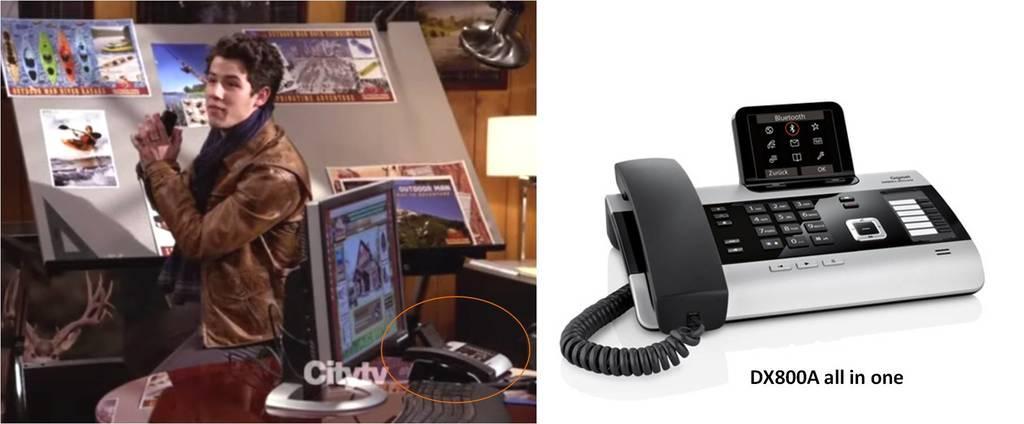Can you describe this image briefly? In the picture we can see two images in the first image we can see a man standing near the board on it, we can see some magazines are pasted and behind the man we can see a desk with monitor, keyboard and telephone and in the second image we can see a telephone which is black and gray in color. 